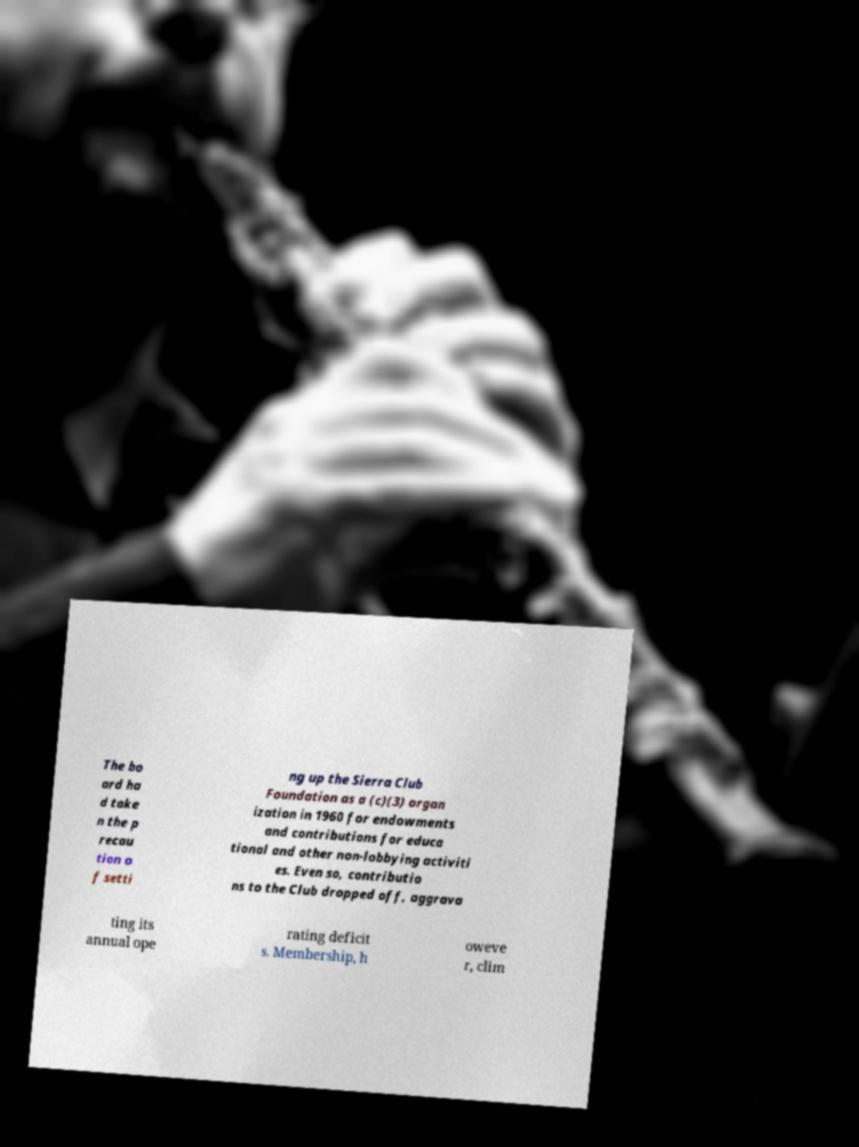Please identify and transcribe the text found in this image. The bo ard ha d take n the p recau tion o f setti ng up the Sierra Club Foundation as a (c)(3) organ ization in 1960 for endowments and contributions for educa tional and other non-lobbying activiti es. Even so, contributio ns to the Club dropped off, aggrava ting its annual ope rating deficit s. Membership, h oweve r, clim 